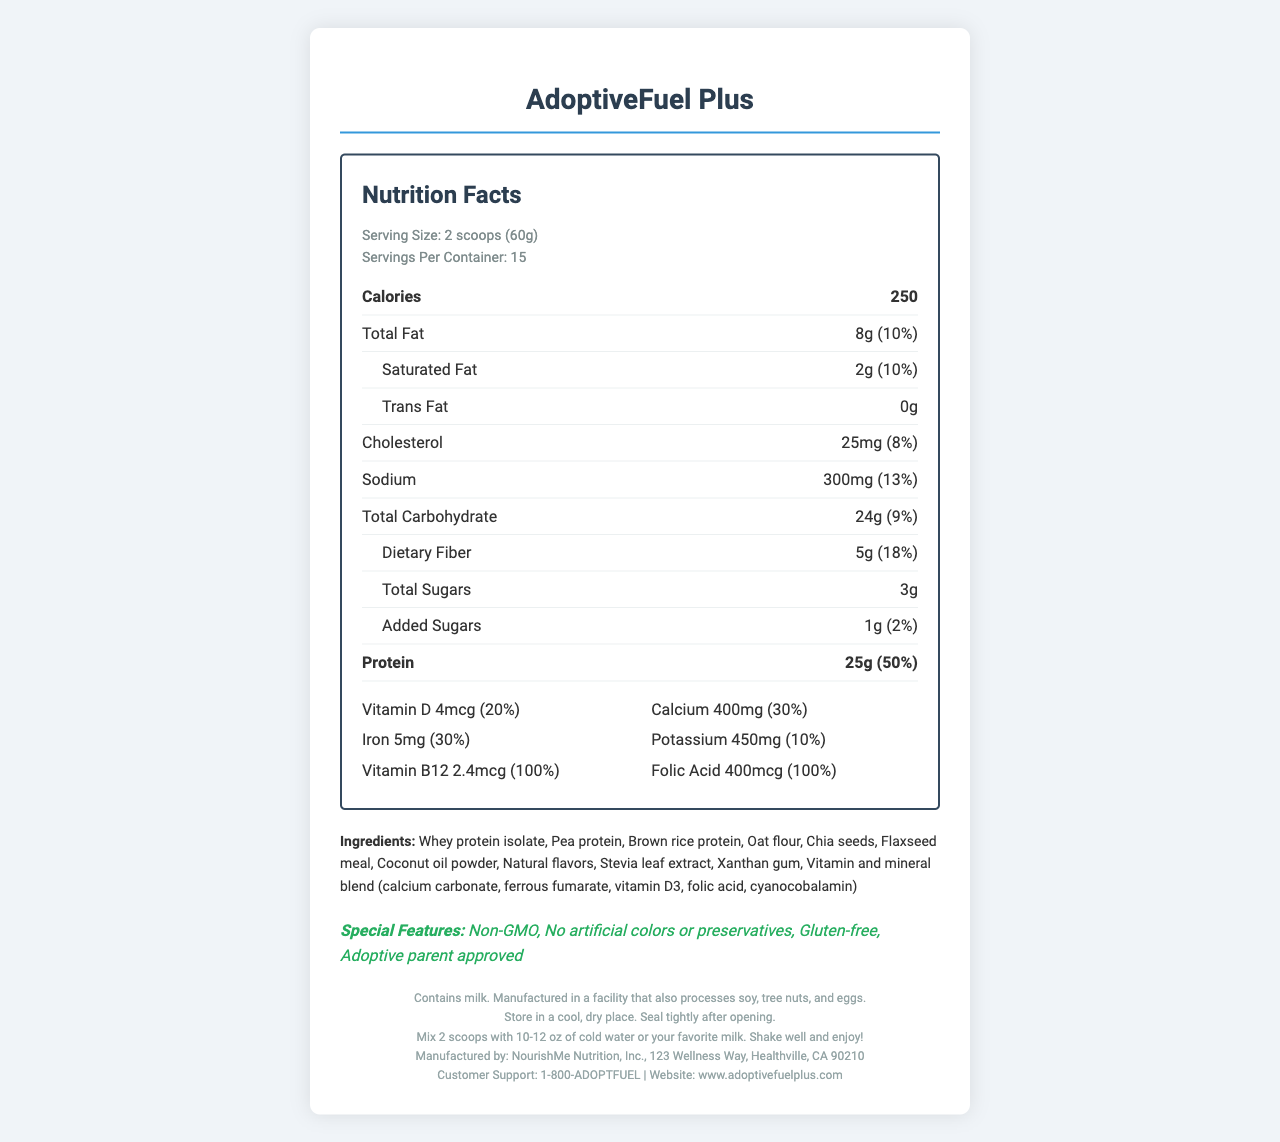what is the name of the product? The document title and headers prominently indicate the product name as "AdoptiveFuel Plus".
Answer: AdoptiveFuel Plus how many servings are in one container? The nutrition label lists the number of servings per container as 15.
Answer: 15 what is the serving size? The serving size is displayed in the serving info section as "2 scoops (60g)".
Answer: 2 scoops (60g) how much protein is in one serving? The protein content per serving is listed as 25g, which corresponds to 50% of the daily value.
Answer: 25g what ingredients are included in the product? The document lists the ingredients section, mentioning all the included ingredients.
Answer: Whey protein isolate, Pea protein, Brown rice protein, Oat flour, Chia seeds, Flaxseed meal, Coconut oil powder, Natural flavors, Stevia leaf extract, Xanthan gum, Vitamin and mineral blend (calcium carbonate, ferrous fumarate, vitamin D3, folic acid, cyanocobalamin) how much dietary fiber is in one serving? The dietary fiber content per serving is listed as 5g, which is 18% of the daily value.
Answer: 5g what special diets is this product suitable for? A. Vegan B. Gluten-free C. Keto D. Paleo Under special features, it is mentioned that the product is "Gluten-free", which makes option B correct.
Answer: B. Gluten-free which vitamin has the highest daily value percentage in one serving? A. Vitamin D B. Calcium C. Iron D. Vitamin B12 Vitamin B12 has a daily value of 100%, higher than the other listed vitamins.
Answer: D. Vitamin B12 does this product contain artificial colors or preservatives? The special features section states that the product has "No artificial colors or preservatives".
Answer: No is this product non-GMO? The special features section explicitly mentions the product as "Non-GMO".
Answer: Yes does this product contain allergens? The allergen info clearly states that the product "Contains milk" and is "Manufactured in a facility that also processes soy, tree nuts, and eggs," indicating potential allergens.
Answer: Yes is the product suitable for people allergic to peanuts? The allergen info mentions milk, soy, tree nuts, and eggs, but does not provide information about peanuts.
Answer: Not enough information how should the product be stored and prepared? The storage instructions specify keeping it in a cool, dry place and sealed tightly after opening. The preparation instructions mention mixing 2 scoops with water or milk and shaking well before consumption.
Answer: Store in a cool, dry place and seal tightly after opening. Mix 2 scoops with 10-12 oz of cold water or your favorite milk, shake well, and enjoy. summarize the main features of the product The document describes AdoptiveFuel Plus as a nutritious meal replacement with key features such as high protein content, essential vitamins and minerals, and special dietary accommodations like being non-GMO and gluten-free. It also includes allergen information, storage, and preparation instructions.
Answer: AdoptiveFuel Plus is a high-protein meal replacement designed for busy adoptive parents. It has 250 calories per serving, provides 25g of protein, and includes essential vitamins and minerals. It is non-GMO, gluten-free, and contains no artificial colors or preservatives. The product is manufactured by NourishMe Nutrition, Inc., and is suitable for those looking for a convenient and nutritious option. 